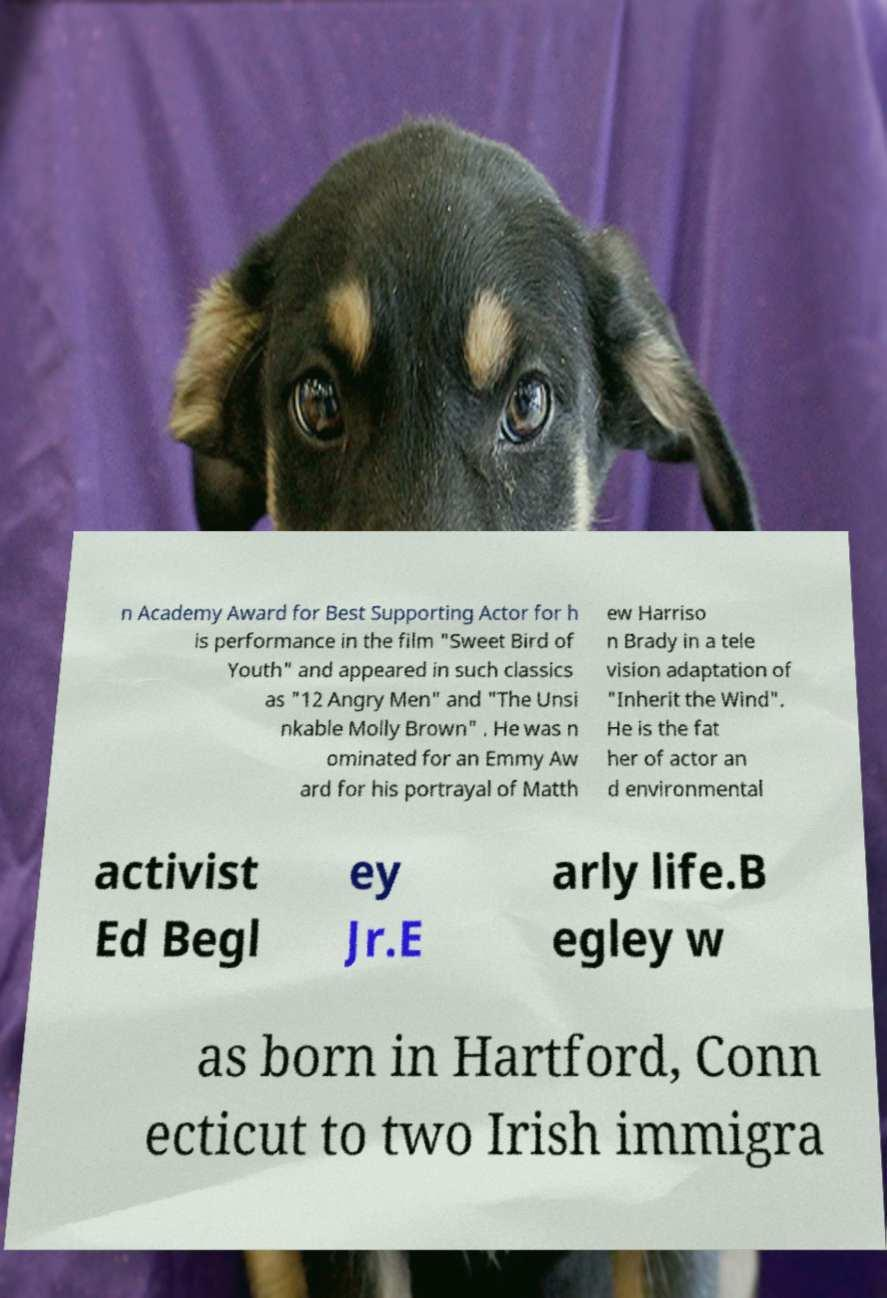What messages or text are displayed in this image? I need them in a readable, typed format. n Academy Award for Best Supporting Actor for h is performance in the film "Sweet Bird of Youth" and appeared in such classics as "12 Angry Men" and "The Unsi nkable Molly Brown" . He was n ominated for an Emmy Aw ard for his portrayal of Matth ew Harriso n Brady in a tele vision adaptation of "Inherit the Wind". He is the fat her of actor an d environmental activist Ed Begl ey Jr.E arly life.B egley w as born in Hartford, Conn ecticut to two Irish immigra 